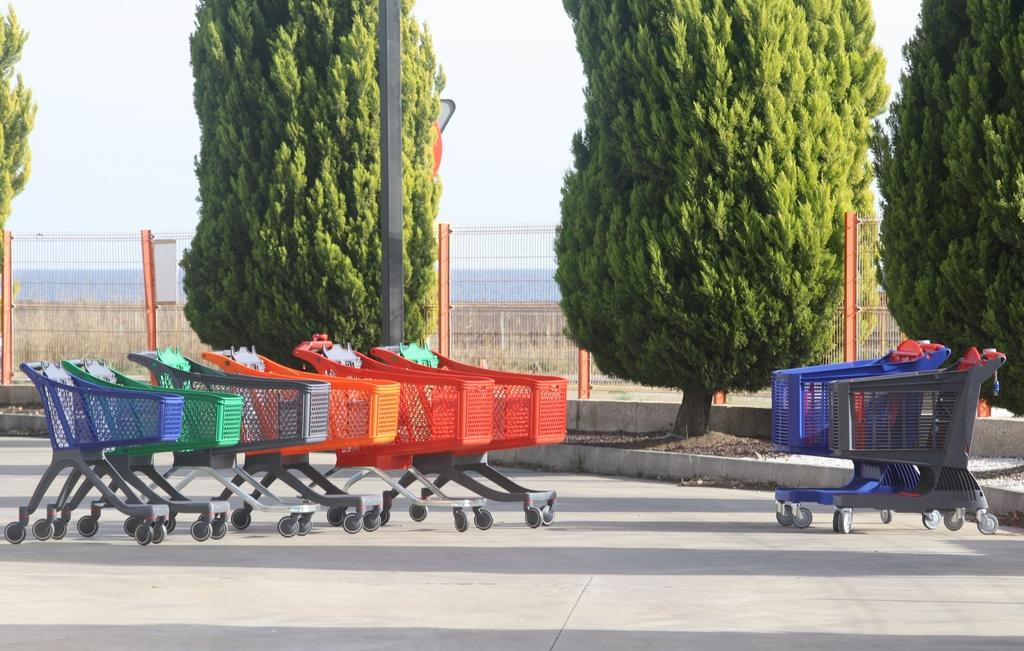What can be seen in the front of the image? There are trolleys in the front of the image. Where are the trolleys located? The trolleys are on the road. What is visible behind the trolleys? There are trees behind the trolleys. What type of barrier is present in the image? There is a fence in the image. What is visible above the trolleys? The sky is visible above the trolleys. What type of lip can be seen on the trolleys in the image? There is no lip present on the trolleys in the image. What songs are being played by the trolleys in the image? The trolleys in the image are not playing any songs. 